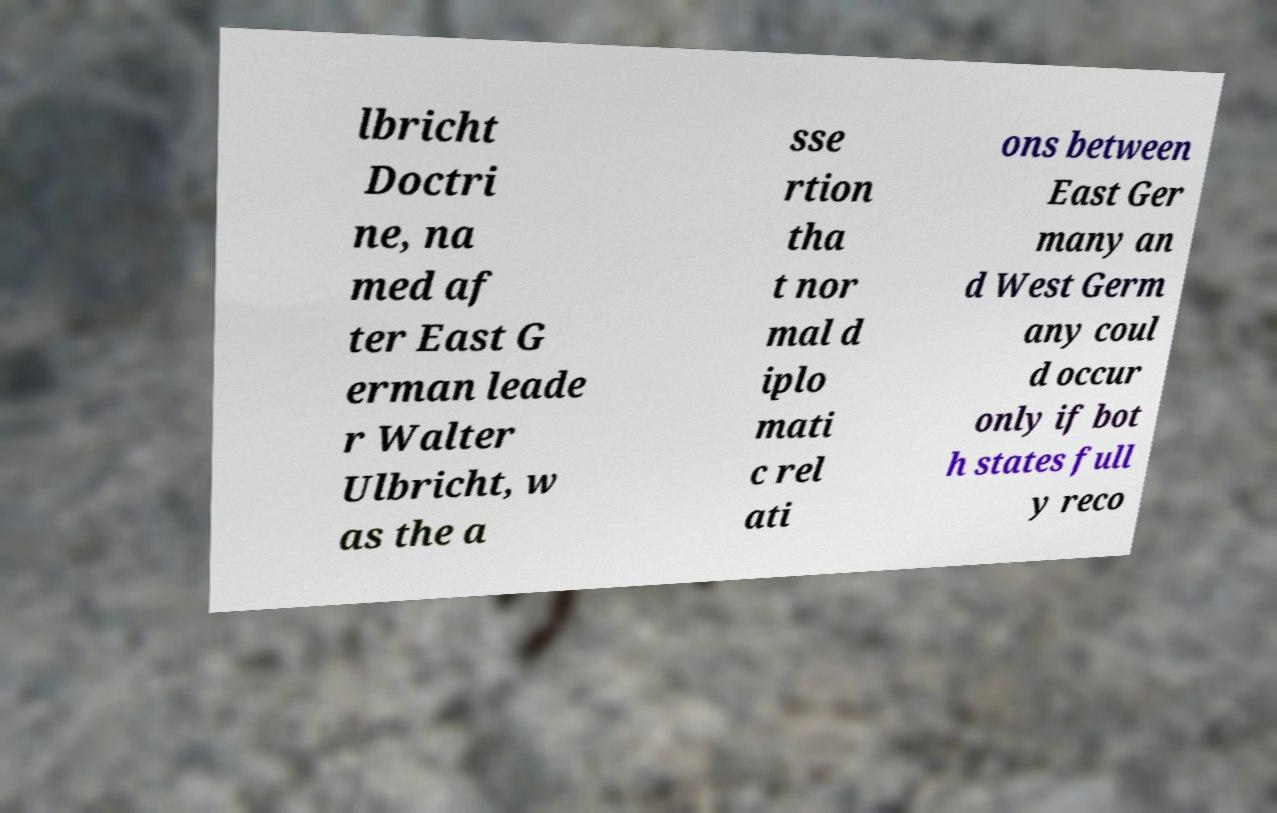I need the written content from this picture converted into text. Can you do that? lbricht Doctri ne, na med af ter East G erman leade r Walter Ulbricht, w as the a sse rtion tha t nor mal d iplo mati c rel ati ons between East Ger many an d West Germ any coul d occur only if bot h states full y reco 